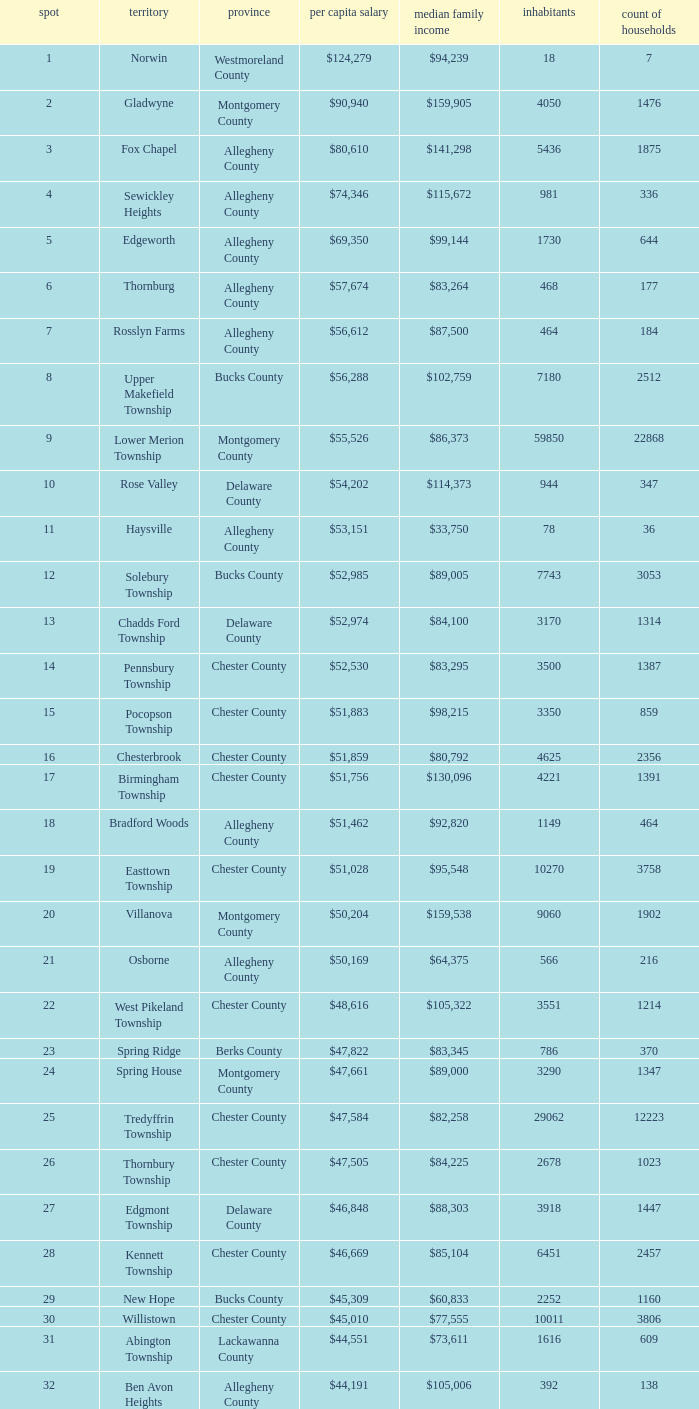Which county has a median household income of  $98,090? Bucks County. 